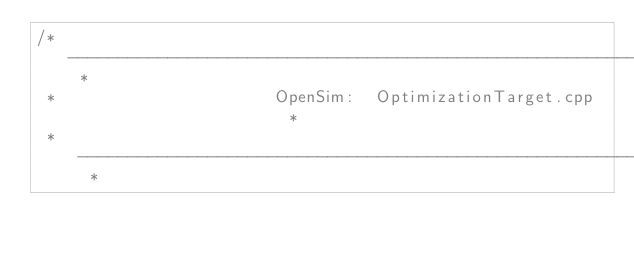Convert code to text. <code><loc_0><loc_0><loc_500><loc_500><_C++_>/* -------------------------------------------------------------------------- *
 *                      OpenSim:  OptimizationTarget.cpp                      *
 * -------------------------------------------------------------------------- *</code> 